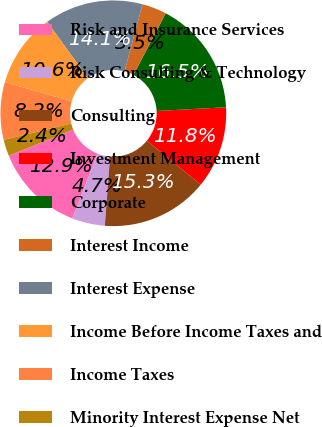<chart> <loc_0><loc_0><loc_500><loc_500><pie_chart><fcel>Risk and Insurance Services<fcel>Risk Consulting & Technology<fcel>Consulting<fcel>Investment Management<fcel>Corporate<fcel>Interest Income<fcel>Interest Expense<fcel>Income Before Income Taxes and<fcel>Income Taxes<fcel>Minority Interest Expense Net<nl><fcel>12.94%<fcel>4.71%<fcel>15.29%<fcel>11.76%<fcel>16.47%<fcel>3.53%<fcel>14.12%<fcel>10.59%<fcel>8.24%<fcel>2.36%<nl></chart> 